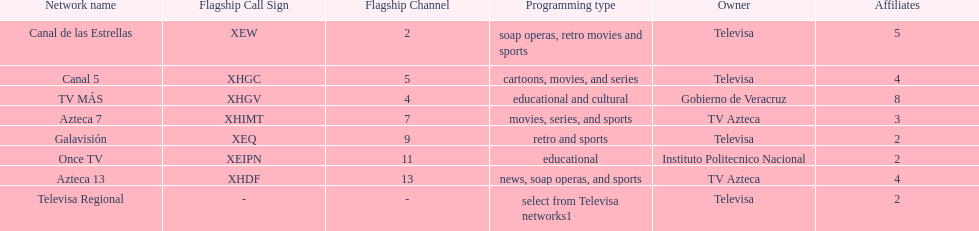Name each of tv azteca's network names. Azteca 7, Azteca 13. Parse the full table. {'header': ['Network name', 'Flagship Call Sign', 'Flagship Channel', 'Programming type', 'Owner', 'Affiliates'], 'rows': [['Canal de las Estrellas', 'XEW', '2', 'soap operas, retro movies and sports', 'Televisa', '5'], ['Canal 5', 'XHGC', '5', 'cartoons, movies, and series', 'Televisa', '4'], ['TV MÁS', 'XHGV', '4', 'educational and cultural', 'Gobierno de Veracruz', '8'], ['Azteca 7', 'XHIMT', '7', 'movies, series, and sports', 'TV Azteca', '3'], ['Galavisión', 'XEQ', '9', 'retro and sports', 'Televisa', '2'], ['Once TV', 'XEIPN', '11', 'educational', 'Instituto Politecnico Nacional', '2'], ['Azteca 13', 'XHDF', '13', 'news, soap operas, and sports', 'TV Azteca', '4'], ['Televisa Regional', '-', '-', 'select from Televisa networks1', 'Televisa', '2']]} 